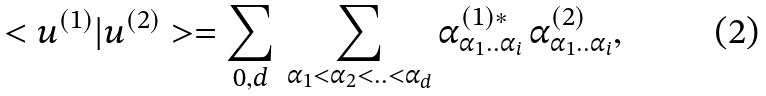Convert formula to latex. <formula><loc_0><loc_0><loc_500><loc_500>< u ^ { ( 1 ) } | u ^ { ( 2 ) } > = \sum _ { 0 , d } \, \sum _ { \alpha _ { 1 } < \alpha _ { 2 } < . . < \alpha _ { d } } \alpha ^ { ( 1 ) * } _ { \alpha _ { 1 } . . \alpha _ { i } } \, \alpha ^ { ( 2 ) } _ { \alpha _ { 1 } . . \alpha _ { i } } ,</formula> 